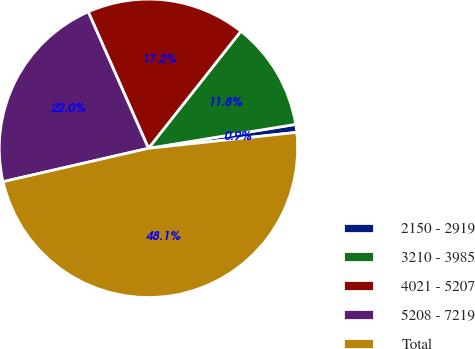<chart> <loc_0><loc_0><loc_500><loc_500><pie_chart><fcel>2150 - 2919<fcel>3210 - 3985<fcel>4021 - 5207<fcel>5208 - 7219<fcel>Total<nl><fcel>0.86%<fcel>11.8%<fcel>17.25%<fcel>21.98%<fcel>48.11%<nl></chart> 